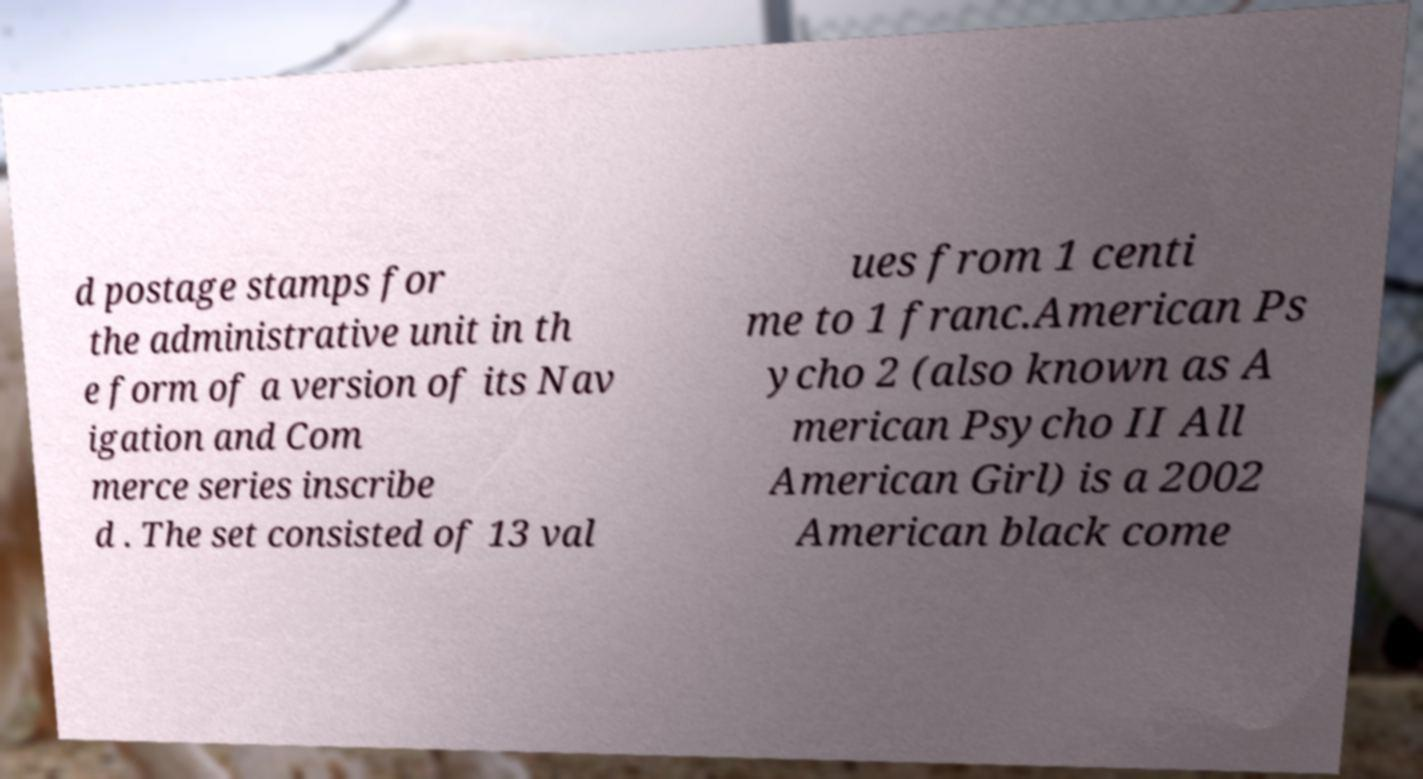I need the written content from this picture converted into text. Can you do that? d postage stamps for the administrative unit in th e form of a version of its Nav igation and Com merce series inscribe d . The set consisted of 13 val ues from 1 centi me to 1 franc.American Ps ycho 2 (also known as A merican Psycho II All American Girl) is a 2002 American black come 